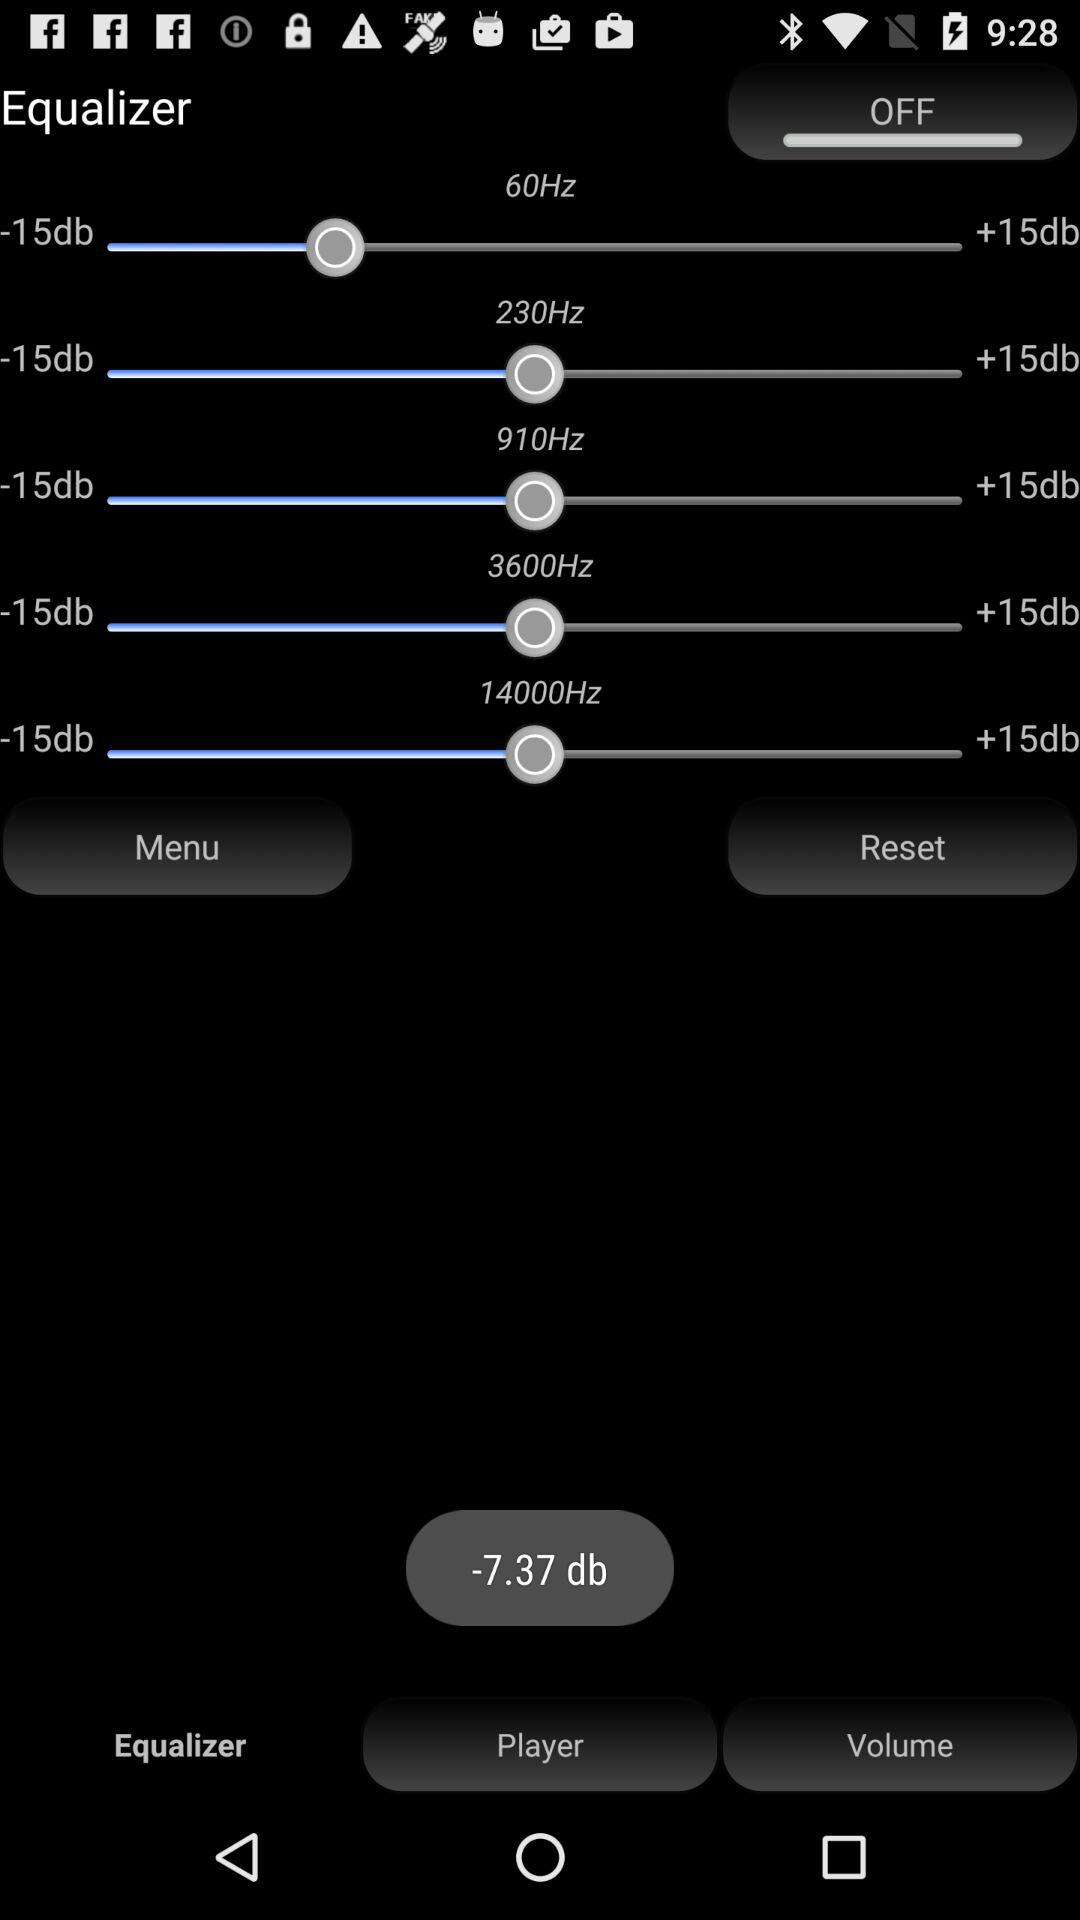Which tab is selected? The selected tab is "Equalizer". 